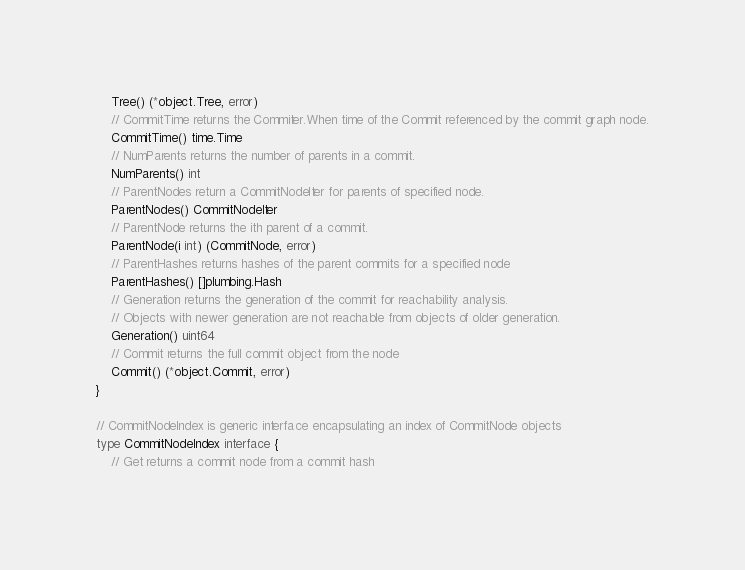Convert code to text. <code><loc_0><loc_0><loc_500><loc_500><_Go_>	Tree() (*object.Tree, error)
	// CommitTime returns the Commiter.When time of the Commit referenced by the commit graph node.
	CommitTime() time.Time
	// NumParents returns the number of parents in a commit.
	NumParents() int
	// ParentNodes return a CommitNodeIter for parents of specified node.
	ParentNodes() CommitNodeIter
	// ParentNode returns the ith parent of a commit.
	ParentNode(i int) (CommitNode, error)
	// ParentHashes returns hashes of the parent commits for a specified node
	ParentHashes() []plumbing.Hash
	// Generation returns the generation of the commit for reachability analysis.
	// Objects with newer generation are not reachable from objects of older generation.
	Generation() uint64
	// Commit returns the full commit object from the node
	Commit() (*object.Commit, error)
}

// CommitNodeIndex is generic interface encapsulating an index of CommitNode objects
type CommitNodeIndex interface {
	// Get returns a commit node from a commit hash</code> 